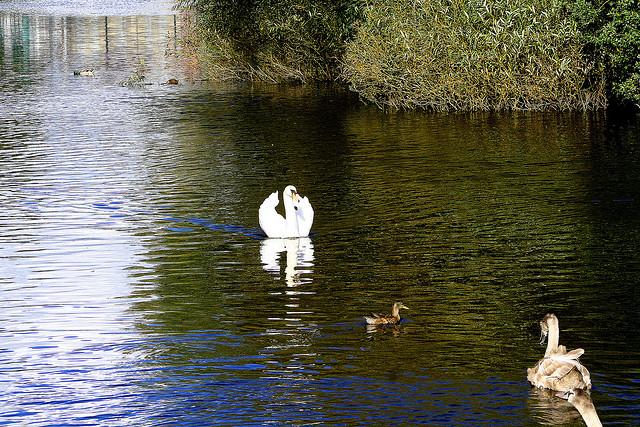What color is the water?
Concise answer only. Brown. What animals are in the water?
Keep it brief. Duck. Is the bird looking for food?
Be succinct. Yes. Are the birds in a natural environment?
Short answer required. Yes. What kind of bird is that?
Give a very brief answer. Swan. Was this photo taken at a zoo?
Keep it brief. No. Are the birds hungry?
Give a very brief answer. No. What animals are they?
Keep it brief. Swan. What is something reflected in the water?
Give a very brief answer. Swan. What type of bird is this?
Answer briefly. Swan. Do all the birds in this photo appear to be the same species?
Write a very short answer. No. How many birds are in the picture?
Write a very short answer. 3. Are the geese in the water?
Quick response, please. Yes. What are the birds doing in the water?
Give a very brief answer. Swimming. Is the bird near shore?
Concise answer only. No. 